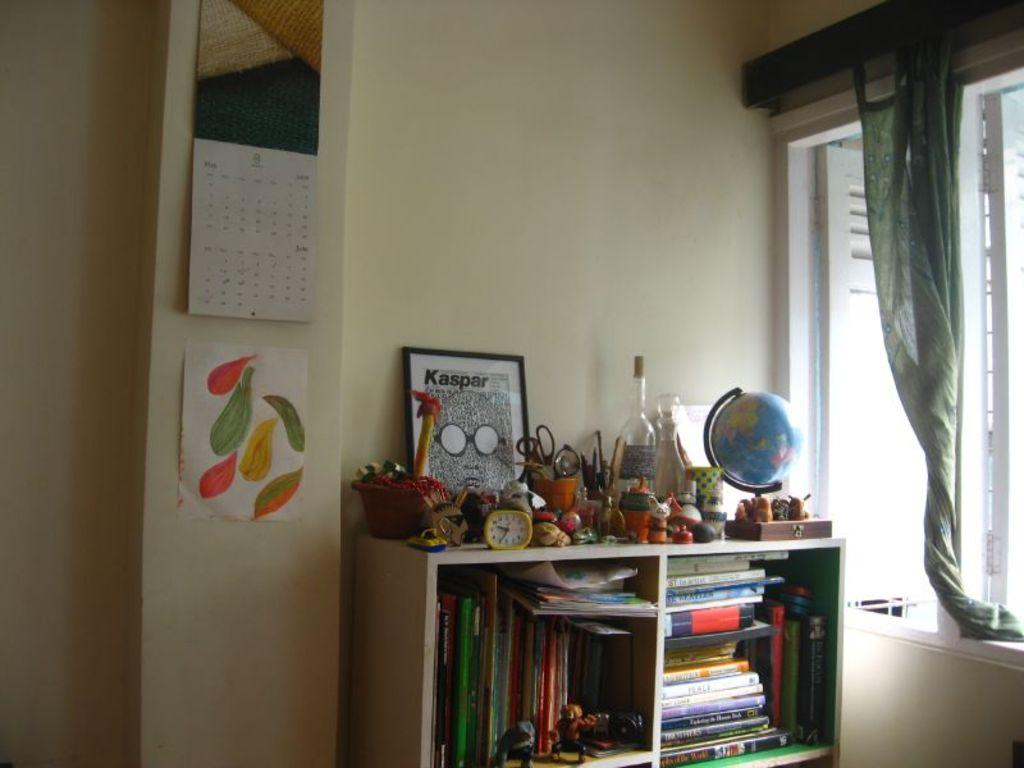<image>
Create a compact narrative representing the image presented. Room with a framed photo saying "Kaspar" and an empty bottle. 